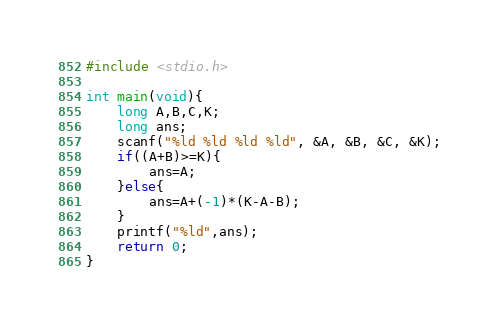Convert code to text. <code><loc_0><loc_0><loc_500><loc_500><_C_>#include <stdio.h>

int main(void){
    long A,B,C,K;
    long ans;
    scanf("%ld %ld %ld %ld", &A, &B, &C, &K);
    if((A+B)>=K){
        ans=A;
    }else{
        ans=A+(-1)*(K-A-B);
    }
    printf("%ld",ans);
    return 0;
}</code> 